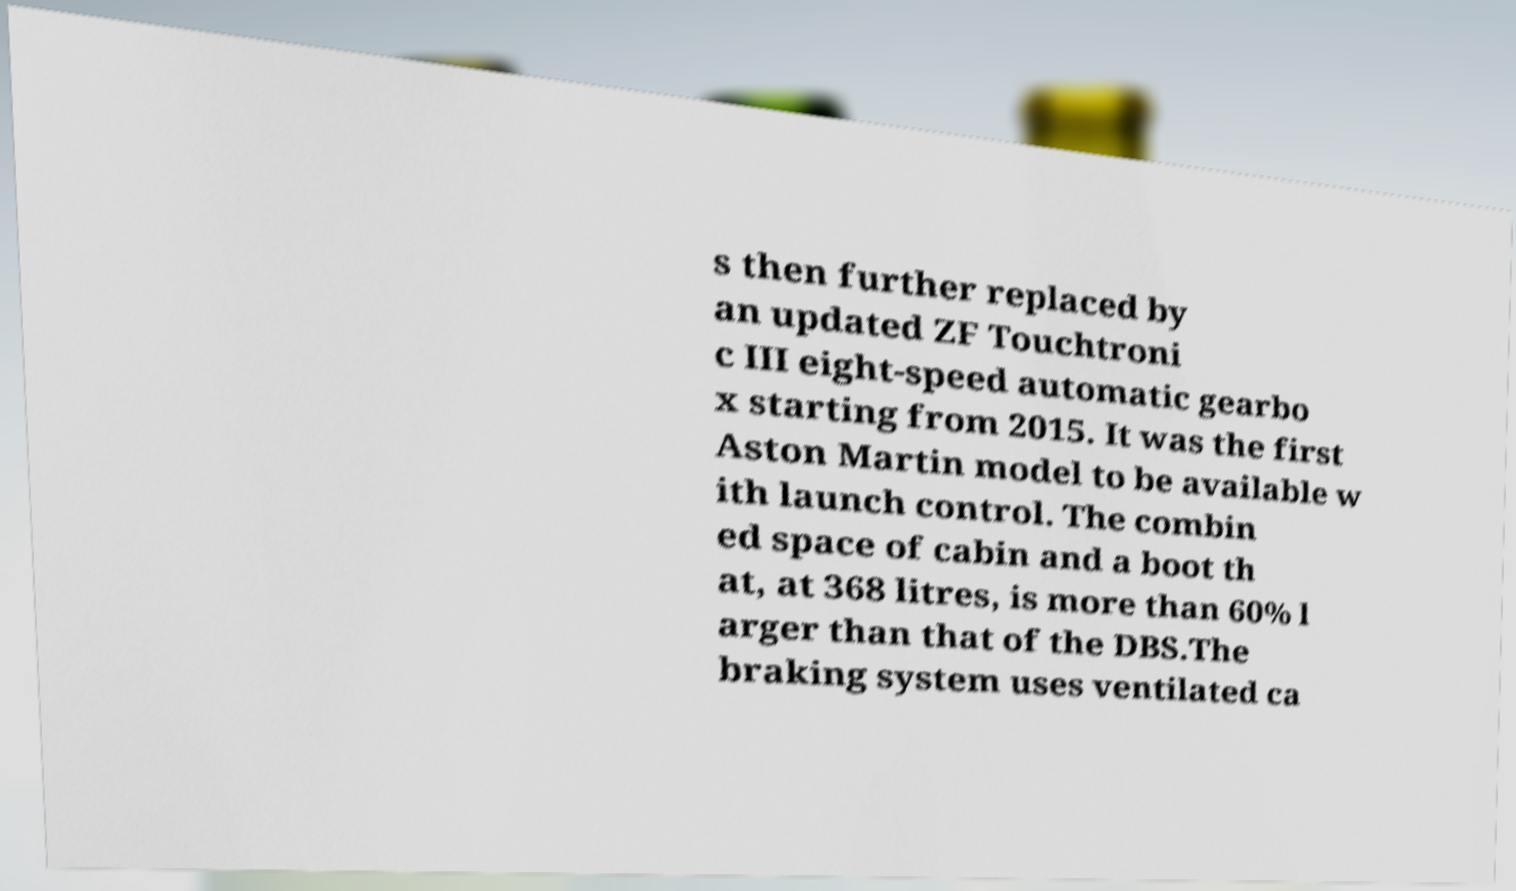I need the written content from this picture converted into text. Can you do that? s then further replaced by an updated ZF Touchtroni c III eight-speed automatic gearbo x starting from 2015. It was the first Aston Martin model to be available w ith launch control. The combin ed space of cabin and a boot th at, at 368 litres, is more than 60% l arger than that of the DBS.The braking system uses ventilated ca 